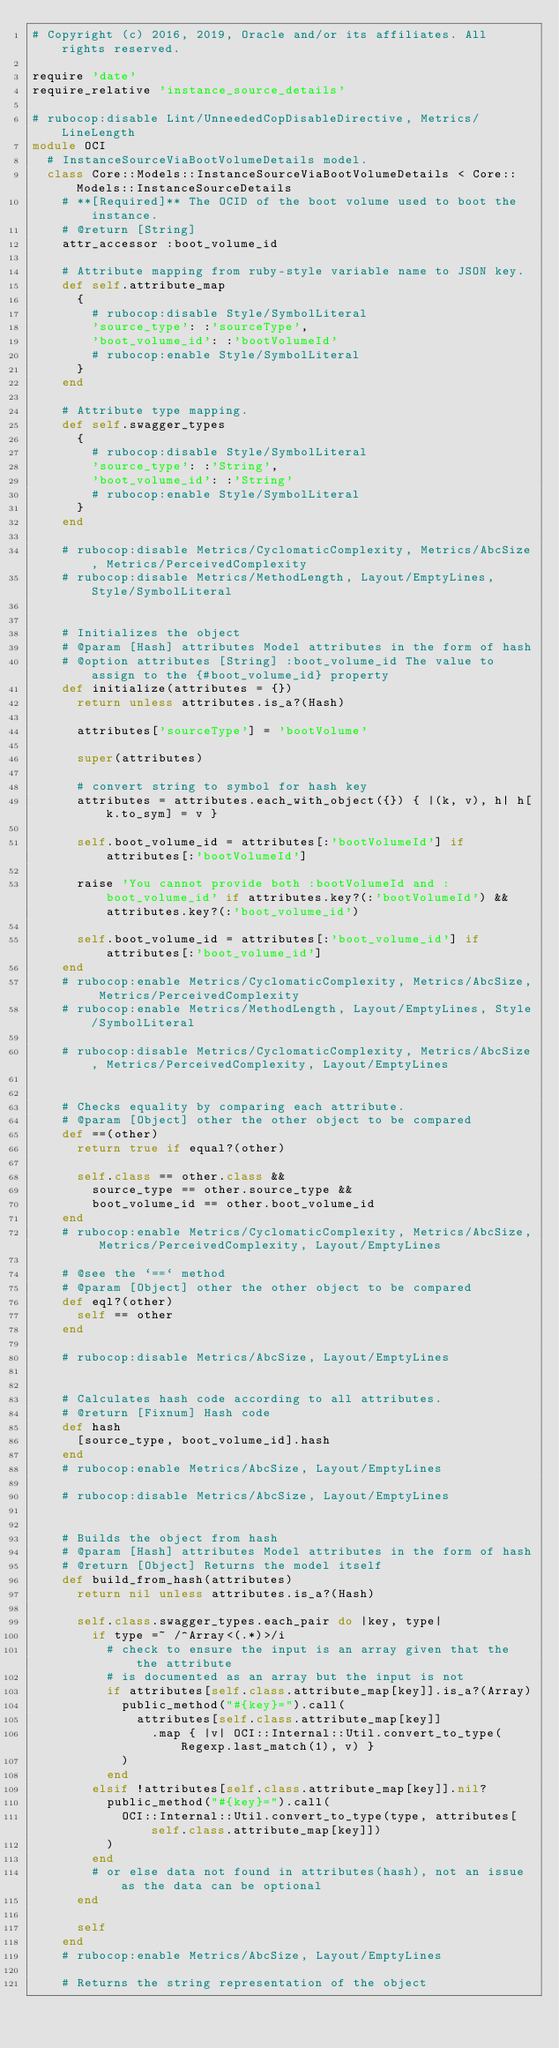Convert code to text. <code><loc_0><loc_0><loc_500><loc_500><_Ruby_># Copyright (c) 2016, 2019, Oracle and/or its affiliates. All rights reserved.

require 'date'
require_relative 'instance_source_details'

# rubocop:disable Lint/UnneededCopDisableDirective, Metrics/LineLength
module OCI
  # InstanceSourceViaBootVolumeDetails model.
  class Core::Models::InstanceSourceViaBootVolumeDetails < Core::Models::InstanceSourceDetails
    # **[Required]** The OCID of the boot volume used to boot the instance.
    # @return [String]
    attr_accessor :boot_volume_id

    # Attribute mapping from ruby-style variable name to JSON key.
    def self.attribute_map
      {
        # rubocop:disable Style/SymbolLiteral
        'source_type': :'sourceType',
        'boot_volume_id': :'bootVolumeId'
        # rubocop:enable Style/SymbolLiteral
      }
    end

    # Attribute type mapping.
    def self.swagger_types
      {
        # rubocop:disable Style/SymbolLiteral
        'source_type': :'String',
        'boot_volume_id': :'String'
        # rubocop:enable Style/SymbolLiteral
      }
    end

    # rubocop:disable Metrics/CyclomaticComplexity, Metrics/AbcSize, Metrics/PerceivedComplexity
    # rubocop:disable Metrics/MethodLength, Layout/EmptyLines, Style/SymbolLiteral


    # Initializes the object
    # @param [Hash] attributes Model attributes in the form of hash
    # @option attributes [String] :boot_volume_id The value to assign to the {#boot_volume_id} property
    def initialize(attributes = {})
      return unless attributes.is_a?(Hash)

      attributes['sourceType'] = 'bootVolume'

      super(attributes)

      # convert string to symbol for hash key
      attributes = attributes.each_with_object({}) { |(k, v), h| h[k.to_sym] = v }

      self.boot_volume_id = attributes[:'bootVolumeId'] if attributes[:'bootVolumeId']

      raise 'You cannot provide both :bootVolumeId and :boot_volume_id' if attributes.key?(:'bootVolumeId') && attributes.key?(:'boot_volume_id')

      self.boot_volume_id = attributes[:'boot_volume_id'] if attributes[:'boot_volume_id']
    end
    # rubocop:enable Metrics/CyclomaticComplexity, Metrics/AbcSize, Metrics/PerceivedComplexity
    # rubocop:enable Metrics/MethodLength, Layout/EmptyLines, Style/SymbolLiteral

    # rubocop:disable Metrics/CyclomaticComplexity, Metrics/AbcSize, Metrics/PerceivedComplexity, Layout/EmptyLines


    # Checks equality by comparing each attribute.
    # @param [Object] other the other object to be compared
    def ==(other)
      return true if equal?(other)

      self.class == other.class &&
        source_type == other.source_type &&
        boot_volume_id == other.boot_volume_id
    end
    # rubocop:enable Metrics/CyclomaticComplexity, Metrics/AbcSize, Metrics/PerceivedComplexity, Layout/EmptyLines

    # @see the `==` method
    # @param [Object] other the other object to be compared
    def eql?(other)
      self == other
    end

    # rubocop:disable Metrics/AbcSize, Layout/EmptyLines


    # Calculates hash code according to all attributes.
    # @return [Fixnum] Hash code
    def hash
      [source_type, boot_volume_id].hash
    end
    # rubocop:enable Metrics/AbcSize, Layout/EmptyLines

    # rubocop:disable Metrics/AbcSize, Layout/EmptyLines


    # Builds the object from hash
    # @param [Hash] attributes Model attributes in the form of hash
    # @return [Object] Returns the model itself
    def build_from_hash(attributes)
      return nil unless attributes.is_a?(Hash)

      self.class.swagger_types.each_pair do |key, type|
        if type =~ /^Array<(.*)>/i
          # check to ensure the input is an array given that the the attribute
          # is documented as an array but the input is not
          if attributes[self.class.attribute_map[key]].is_a?(Array)
            public_method("#{key}=").call(
              attributes[self.class.attribute_map[key]]
                .map { |v| OCI::Internal::Util.convert_to_type(Regexp.last_match(1), v) }
            )
          end
        elsif !attributes[self.class.attribute_map[key]].nil?
          public_method("#{key}=").call(
            OCI::Internal::Util.convert_to_type(type, attributes[self.class.attribute_map[key]])
          )
        end
        # or else data not found in attributes(hash), not an issue as the data can be optional
      end

      self
    end
    # rubocop:enable Metrics/AbcSize, Layout/EmptyLines

    # Returns the string representation of the object</code> 